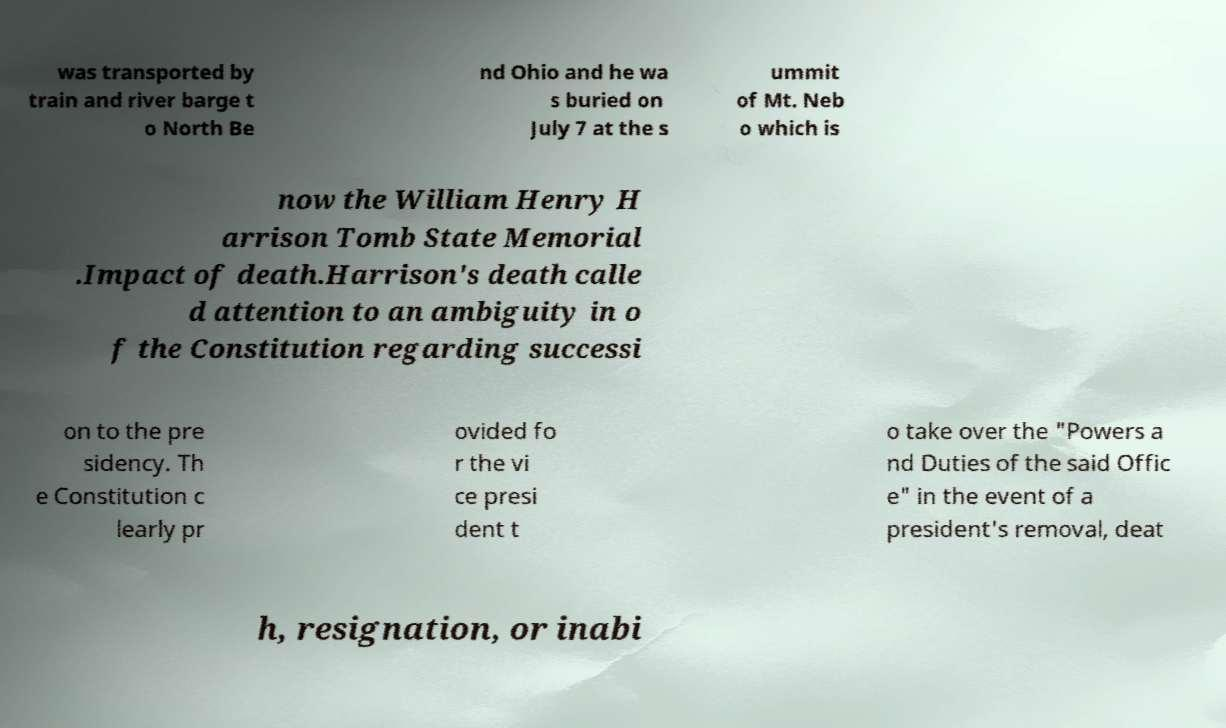There's text embedded in this image that I need extracted. Can you transcribe it verbatim? was transported by train and river barge t o North Be nd Ohio and he wa s buried on July 7 at the s ummit of Mt. Neb o which is now the William Henry H arrison Tomb State Memorial .Impact of death.Harrison's death calle d attention to an ambiguity in o f the Constitution regarding successi on to the pre sidency. Th e Constitution c learly pr ovided fo r the vi ce presi dent t o take over the "Powers a nd Duties of the said Offic e" in the event of a president's removal, deat h, resignation, or inabi 